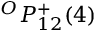<formula> <loc_0><loc_0><loc_500><loc_500>{ } ^ { O } { P } _ { 1 { 2 } } ^ { + } ( { 4 } )</formula> 